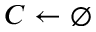<formula> <loc_0><loc_0><loc_500><loc_500>C \gets \emptyset</formula> 